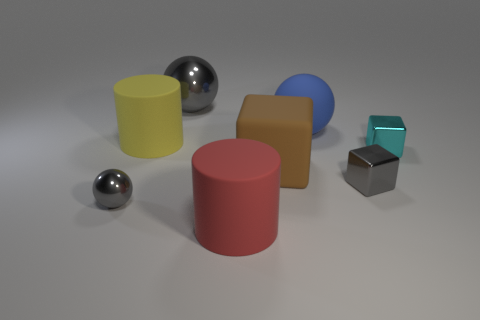There is a red thing; is its size the same as the cylinder that is on the left side of the big red thing?
Give a very brief answer. Yes. The big cylinder to the left of the gray object behind the small shiny cube behind the tiny gray block is what color?
Your answer should be very brief. Yellow. The large matte cube has what color?
Your response must be concise. Brown. Is the number of cyan metallic things behind the small cyan shiny block greater than the number of small gray things that are in front of the red cylinder?
Give a very brief answer. No. Is the shape of the large brown matte object the same as the large red rubber object that is to the left of the cyan shiny cube?
Your response must be concise. No. Does the gray object that is behind the brown matte object have the same size as the rubber cylinder behind the large red cylinder?
Your response must be concise. Yes. Are there any large brown matte blocks to the right of the big brown thing that is in front of the rubber object left of the large gray metal ball?
Offer a terse response. No. Is the number of big blue matte objects right of the big matte sphere less than the number of red objects that are in front of the tiny cyan block?
Provide a succinct answer. Yes. What shape is the blue thing that is the same material as the large block?
Offer a terse response. Sphere. There is a matte cylinder that is behind the tiny metal object left of the big object that is in front of the big brown rubber block; what is its size?
Provide a succinct answer. Large. 